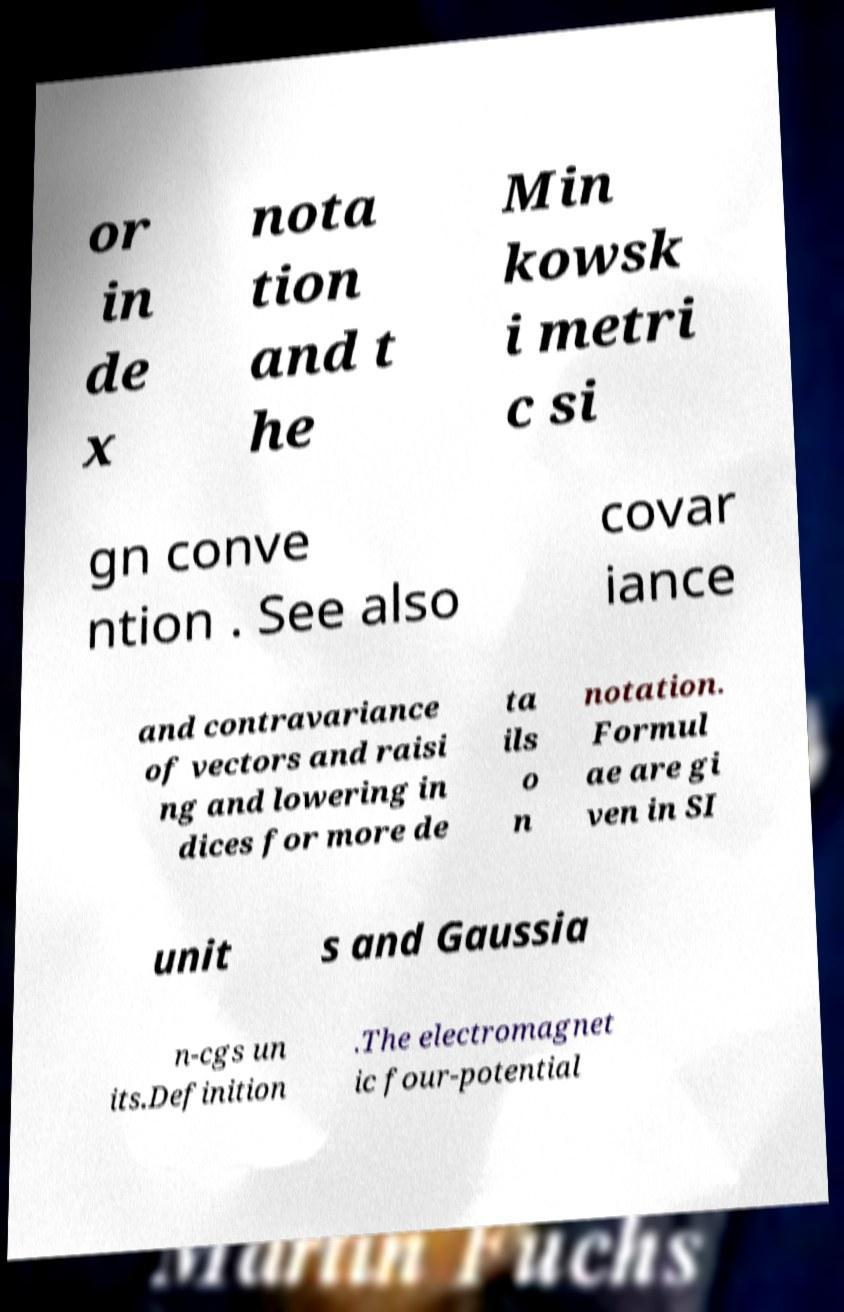Can you accurately transcribe the text from the provided image for me? or in de x nota tion and t he Min kowsk i metri c si gn conve ntion . See also covar iance and contravariance of vectors and raisi ng and lowering in dices for more de ta ils o n notation. Formul ae are gi ven in SI unit s and Gaussia n-cgs un its.Definition .The electromagnet ic four-potential 